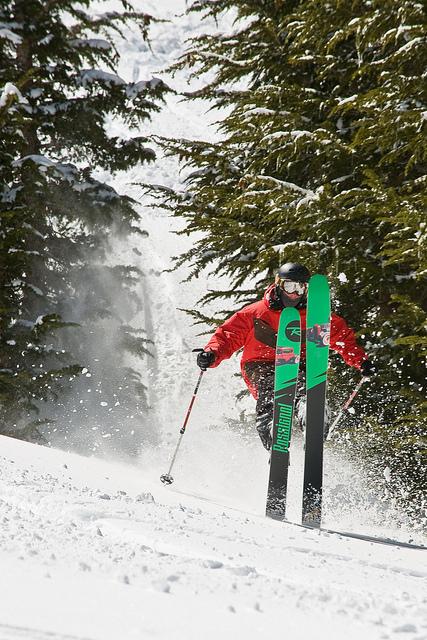What color are the skier's skis?
Concise answer only. Green. Is this person skilled at skiing?
Short answer required. Yes. Is it snowing?
Answer briefly. No. 